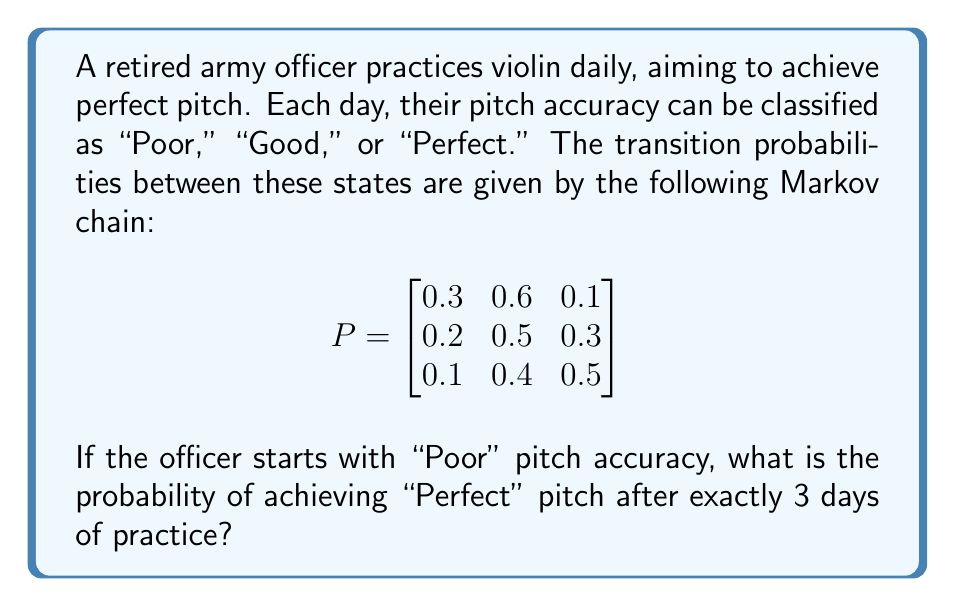Provide a solution to this math problem. To solve this problem, we need to use the Markov chain transition matrix and calculate the probability of moving from the "Poor" state to the "Perfect" state in exactly 3 steps.

Step 1: Identify the initial state vector.
Since the officer starts with "Poor" pitch accuracy, the initial state vector is:
$$v_0 = \begin{bmatrix} 1 & 0 & 0 \end{bmatrix}$$

Step 2: Calculate the transition matrix for 3 steps.
We need to raise the given transition matrix P to the power of 3:
$$P^3 = P \times P \times P$$

Step 3: Perform the matrix multiplication.
Using a calculator or computer algebra system, we get:
$$P^3 = \begin{bmatrix}
0.219 & 0.513 & 0.268 \\
0.207 & 0.503 & 0.290 \\
0.193 & 0.491 & 0.316
\end{bmatrix}$$

Step 4: Extract the probability of reaching "Perfect" pitch.
The probability of moving from "Poor" to "Perfect" in 3 steps is given by the element in the first row, third column of $P^3$, which is 0.268.

Therefore, the probability of achieving "Perfect" pitch after exactly 3 days of practice, starting from "Poor" pitch accuracy, is 0.268 or 26.8%.
Answer: 0.268 